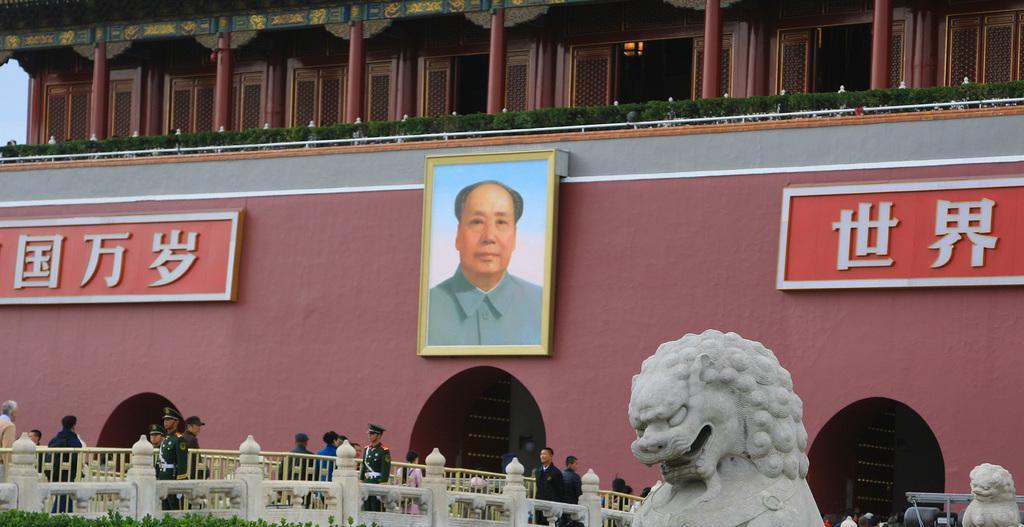Can you describe this image briefly? In this image we can see there are boards and photo frames attached to the building. And there are people walking on the ground and there is a sculpture, grass, fence and the sky. 